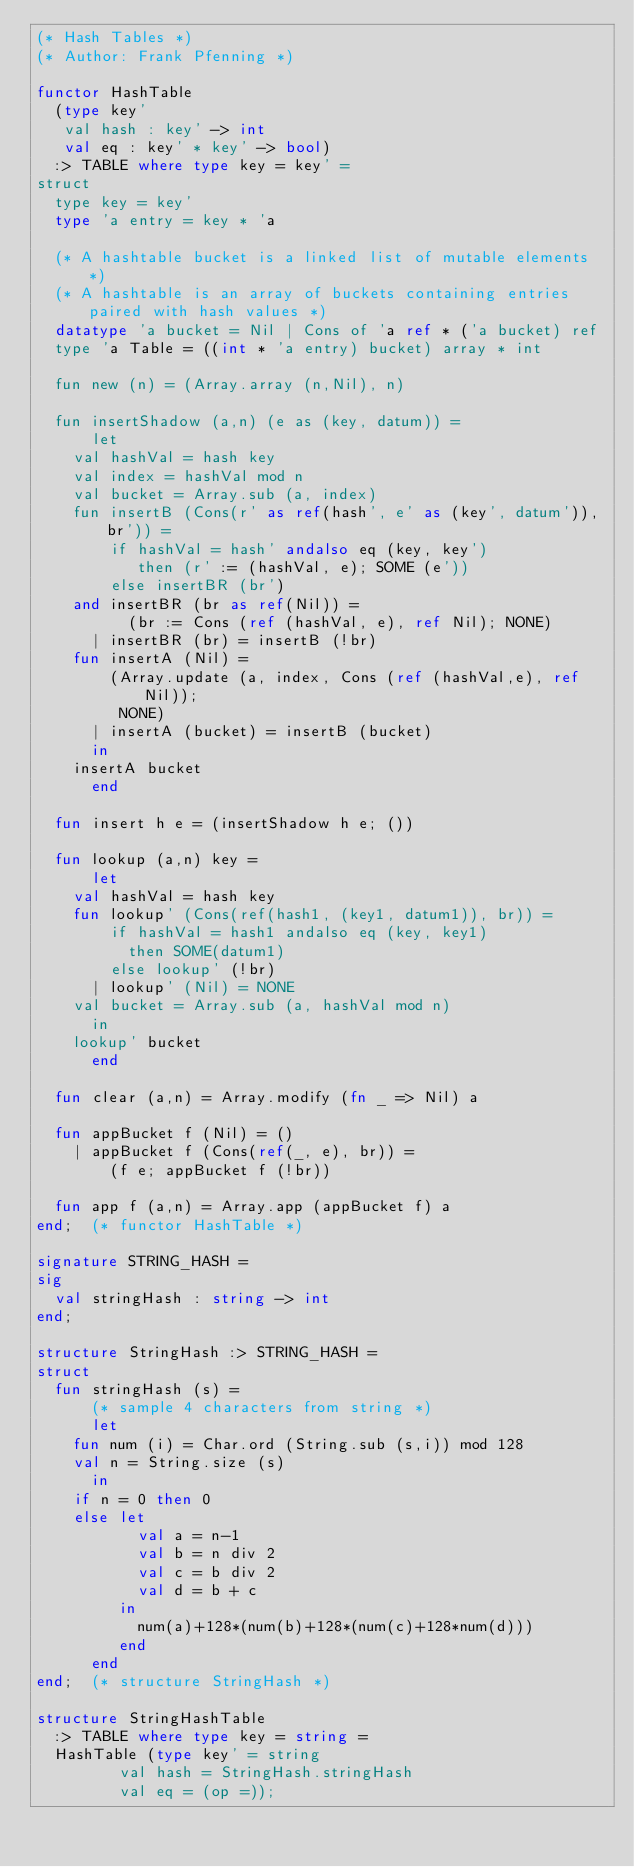Convert code to text. <code><loc_0><loc_0><loc_500><loc_500><_SML_>(* Hash Tables *)
(* Author: Frank Pfenning *)

functor HashTable
  (type key'
   val hash : key' -> int
   val eq : key' * key' -> bool)
  :> TABLE where type key = key' =
struct
  type key = key'
  type 'a entry = key * 'a

  (* A hashtable bucket is a linked list of mutable elements *)
  (* A hashtable is an array of buckets containing entries paired with hash values *)
  datatype 'a bucket = Nil | Cons of 'a ref * ('a bucket) ref
  type 'a Table = ((int * 'a entry) bucket) array * int

  fun new (n) = (Array.array (n,Nil), n)

  fun insertShadow (a,n) (e as (key, datum)) =
      let
	val hashVal = hash key
	val index = hashVal mod n
	val bucket = Array.sub (a, index)
	fun insertB (Cons(r' as ref(hash', e' as (key', datum')), br')) =
	    if hashVal = hash' andalso eq (key, key')
	       then (r' := (hashVal, e); SOME (e'))
	    else insertBR (br')
	and insertBR (br as ref(Nil)) =
	      (br := Cons (ref (hashVal, e), ref Nil); NONE)
	  | insertBR (br) = insertB (!br)
	fun insertA (Nil) =
	    (Array.update (a, index, Cons (ref (hashVal,e), ref Nil));
	     NONE)
	  | insertA (bucket) = insertB (bucket)
      in
	insertA bucket
      end

  fun insert h e = (insertShadow h e; ())

  fun lookup (a,n) key =
      let
	val hashVal = hash key
	fun lookup' (Cons(ref(hash1, (key1, datum1)), br)) =
	    if hashVal = hash1 andalso eq (key, key1)
	      then SOME(datum1)
	    else lookup' (!br)
	  | lookup' (Nil) = NONE
	val bucket = Array.sub (a, hashVal mod n)
      in
	lookup' bucket
      end

  fun clear (a,n) = Array.modify (fn _ => Nil) a

  fun appBucket f (Nil) = ()
    | appBucket f (Cons(ref(_, e), br)) =
        (f e; appBucket f (!br))

  fun app f (a,n) = Array.app (appBucket f) a
end;  (* functor HashTable *)

signature STRING_HASH =
sig
  val stringHash : string -> int
end;

structure StringHash :> STRING_HASH =
struct
  fun stringHash (s) =
      (* sample 4 characters from string *)
      let
	fun num (i) = Char.ord (String.sub (s,i)) mod 128
	val n = String.size (s)
      in
	if n = 0 then 0
	else let
	       val a = n-1
	       val b = n div 2
	       val c = b div 2
	       val d = b + c
	     in
	       num(a)+128*(num(b)+128*(num(c)+128*num(d)))
	     end
      end
end;  (* structure StringHash *)

structure StringHashTable
  :> TABLE where type key = string =
  HashTable (type key' = string
	     val hash = StringHash.stringHash
	     val eq = (op =));
</code> 